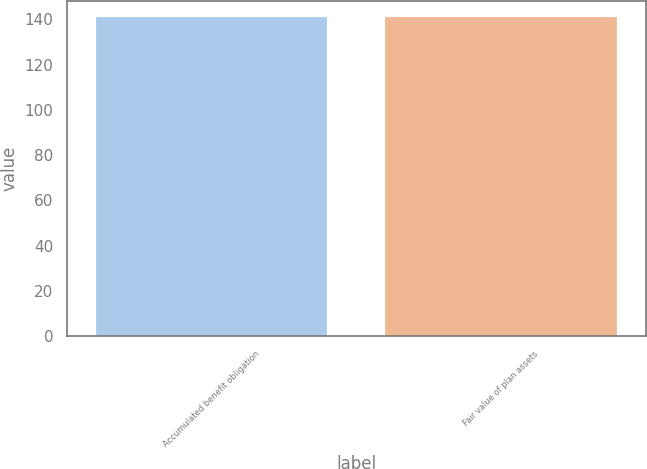<chart> <loc_0><loc_0><loc_500><loc_500><bar_chart><fcel>Accumulated benefit obligation<fcel>Fair value of plan assets<nl><fcel>141<fcel>141.1<nl></chart> 